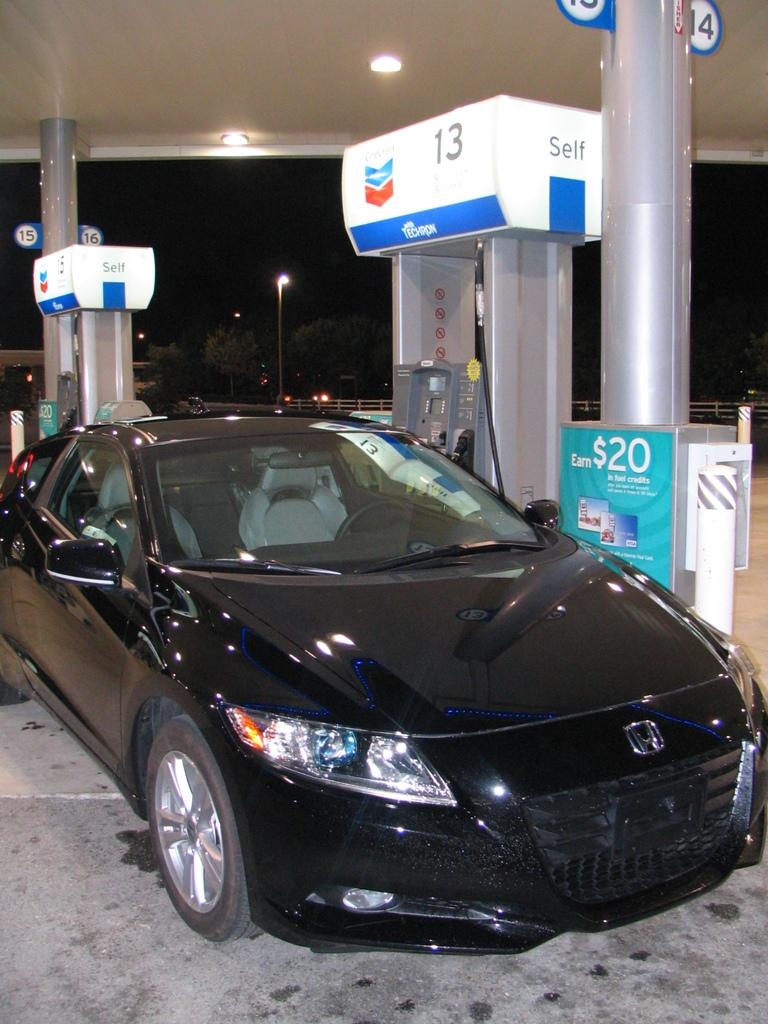What is located on the ground in the image? There is a car on the ground in the image. What type of decorations or advertisements can be seen in the image? There are posters in the image. What kind of equipment or devices are present in the image? There are machines in the image. What structures can be seen supporting wires or cables in the image? There are poles in the image. What objects are used for displaying information or numbers in the image? There are number boards in the image. What type of natural vegetation is visible in the image? There are trees in the image. What type of barrier or enclosure can be seen in the image? There is a fence in the image. What type of covering or shelter is visible in the image? There is a roof in the image. What type of illumination is present in the image? There are lights in the image. How would you describe the overall lighting conditions in the image? The background of the image is dark. Can you tell me where the stomach of the person in the image is located? There is no person present in the image, so it is not possible to determine the location of their stomach. What type of pipe can be seen running along the seashore in the image? There is no seashore present in the image, so it is not possible to determine if there are any pipes or their location. 